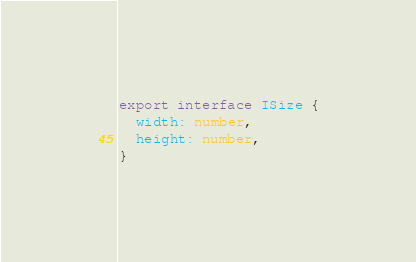<code> <loc_0><loc_0><loc_500><loc_500><_TypeScript_>export interface ISize {
  width: number, 
  height: number,
}
</code> 